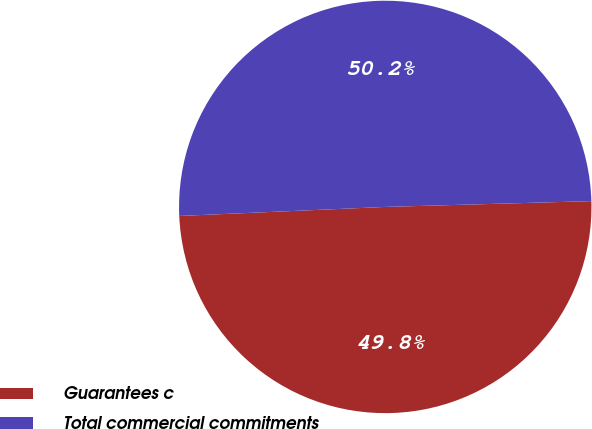<chart> <loc_0><loc_0><loc_500><loc_500><pie_chart><fcel>Guarantees c<fcel>Total commercial commitments<nl><fcel>49.75%<fcel>50.25%<nl></chart> 